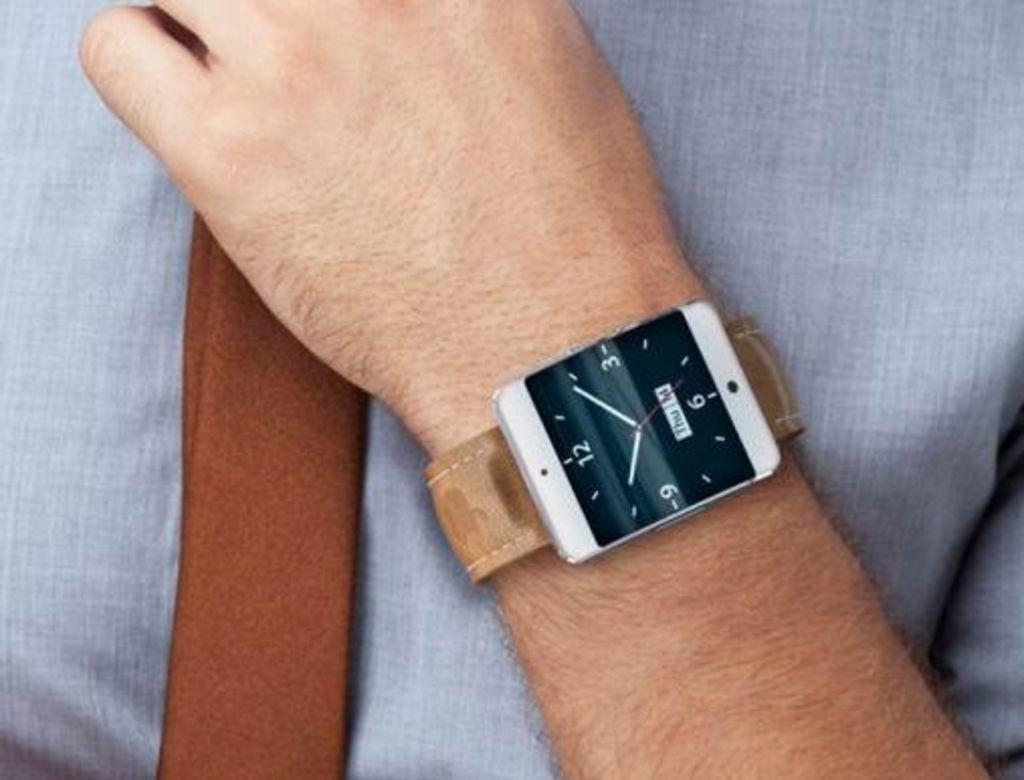<image>
Write a terse but informative summary of the picture. A square watch that has the date of Thrus the 14th 